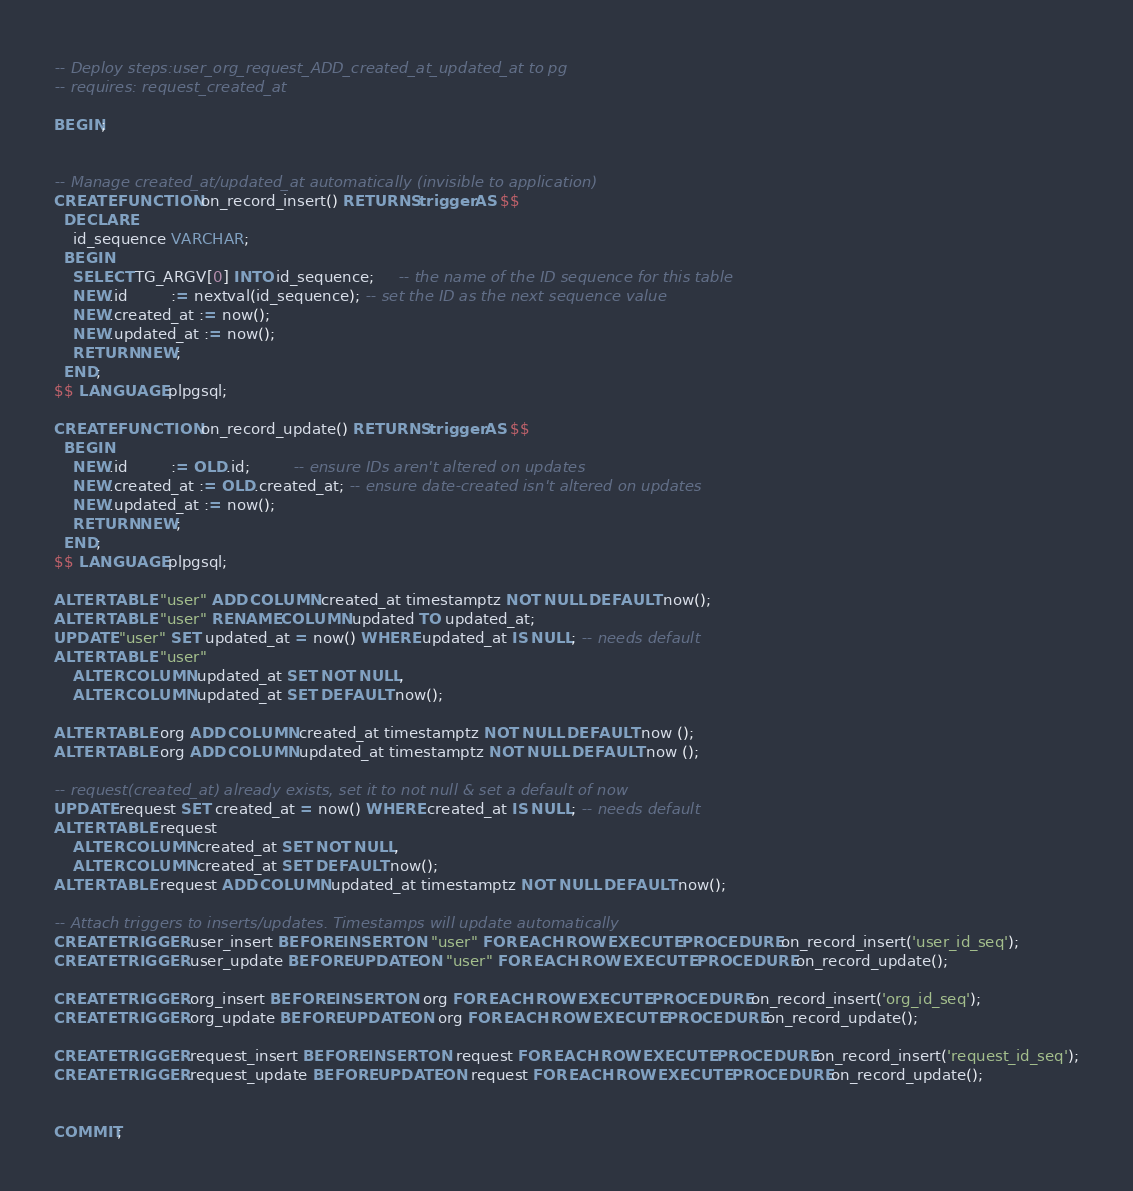Convert code to text. <code><loc_0><loc_0><loc_500><loc_500><_SQL_>-- Deploy steps:user_org_request_ADD_created_at_updated_at to pg
-- requires: request_created_at

BEGIN;


-- Manage created_at/updated_at automatically (invisible to application)
CREATE FUNCTION on_record_insert() RETURNS trigger AS $$
  DECLARE
    id_sequence VARCHAR;
  BEGIN
    SELECT TG_ARGV[0] INTO id_sequence;     -- the name of the ID sequence for this table
    NEW.id         := nextval(id_sequence); -- set the ID as the next sequence value
    NEW.created_at := now();
    NEW.updated_at := now();
    RETURN NEW;
  END;
$$ LANGUAGE plpgsql;

CREATE FUNCTION on_record_update() RETURNS trigger AS $$
  BEGIN
    NEW.id         := OLD.id;         -- ensure IDs aren't altered on updates
    NEW.created_at := OLD.created_at; -- ensure date-created isn't altered on updates
    NEW.updated_at := now();
    RETURN NEW;
  END;
$$ LANGUAGE plpgsql;

ALTER TABLE "user" ADD COLUMN created_at timestamptz NOT NULL DEFAULT now();
ALTER TABLE "user" RENAME COLUMN updated TO updated_at;
UPDATE "user" SET updated_at = now() WHERE updated_at IS NULL; -- needs default
ALTER TABLE "user"
    ALTER COLUMN updated_at SET NOT NULL,
    ALTER COLUMN updated_at SET DEFAULT now();

ALTER TABLE org ADD COLUMN created_at timestamptz NOT NULL DEFAULT now ();
ALTER TABLE org ADD COLUMN updated_at timestamptz NOT NULL DEFAULT now ();

-- request(created_at) already exists, set it to not null & set a default of now
UPDATE request SET created_at = now() WHERE created_at IS NULL; -- needs default
ALTER TABLE request
    ALTER COLUMN created_at SET NOT NULL,
    ALTER COLUMN created_at SET DEFAULT now();
ALTER TABLE request ADD COLUMN updated_at timestamptz NOT NULL DEFAULT now();

-- Attach triggers to inserts/updates. Timestamps will update automatically
CREATE TRIGGER user_insert BEFORE INSERT ON "user" FOR EACH ROW EXECUTE PROCEDURE on_record_insert('user_id_seq');
CREATE TRIGGER user_update BEFORE UPDATE ON "user" FOR EACH ROW EXECUTE PROCEDURE on_record_update();

CREATE TRIGGER org_insert BEFORE INSERT ON org FOR EACH ROW EXECUTE PROCEDURE on_record_insert('org_id_seq');
CREATE TRIGGER org_update BEFORE UPDATE ON org FOR EACH ROW EXECUTE PROCEDURE on_record_update();

CREATE TRIGGER request_insert BEFORE INSERT ON request FOR EACH ROW EXECUTE PROCEDURE on_record_insert('request_id_seq');
CREATE TRIGGER request_update BEFORE UPDATE ON request FOR EACH ROW EXECUTE PROCEDURE on_record_update();


COMMIT;
</code> 